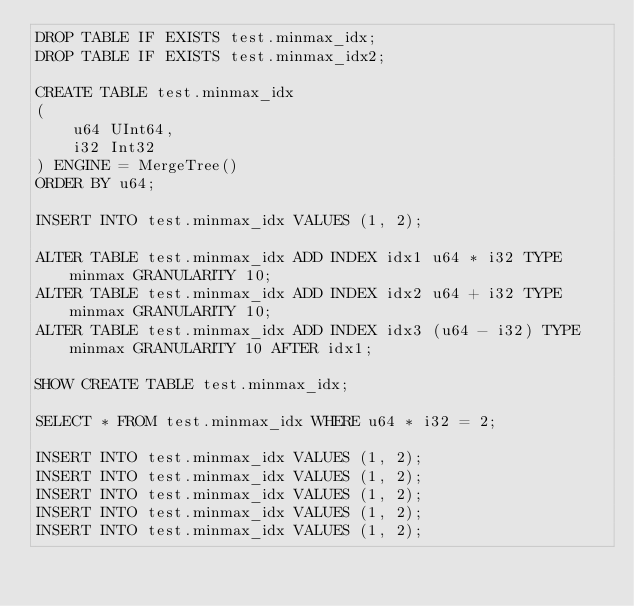<code> <loc_0><loc_0><loc_500><loc_500><_SQL_>DROP TABLE IF EXISTS test.minmax_idx;
DROP TABLE IF EXISTS test.minmax_idx2;

CREATE TABLE test.minmax_idx
(
    u64 UInt64,
    i32 Int32
) ENGINE = MergeTree()
ORDER BY u64;

INSERT INTO test.minmax_idx VALUES (1, 2);

ALTER TABLE test.minmax_idx ADD INDEX idx1 u64 * i32 TYPE minmax GRANULARITY 10;
ALTER TABLE test.minmax_idx ADD INDEX idx2 u64 + i32 TYPE minmax GRANULARITY 10;
ALTER TABLE test.minmax_idx ADD INDEX idx3 (u64 - i32) TYPE minmax GRANULARITY 10 AFTER idx1;

SHOW CREATE TABLE test.minmax_idx;

SELECT * FROM test.minmax_idx WHERE u64 * i32 = 2;

INSERT INTO test.minmax_idx VALUES (1, 2);
INSERT INTO test.minmax_idx VALUES (1, 2);
INSERT INTO test.minmax_idx VALUES (1, 2);
INSERT INTO test.minmax_idx VALUES (1, 2);
INSERT INTO test.minmax_idx VALUES (1, 2);
</code> 